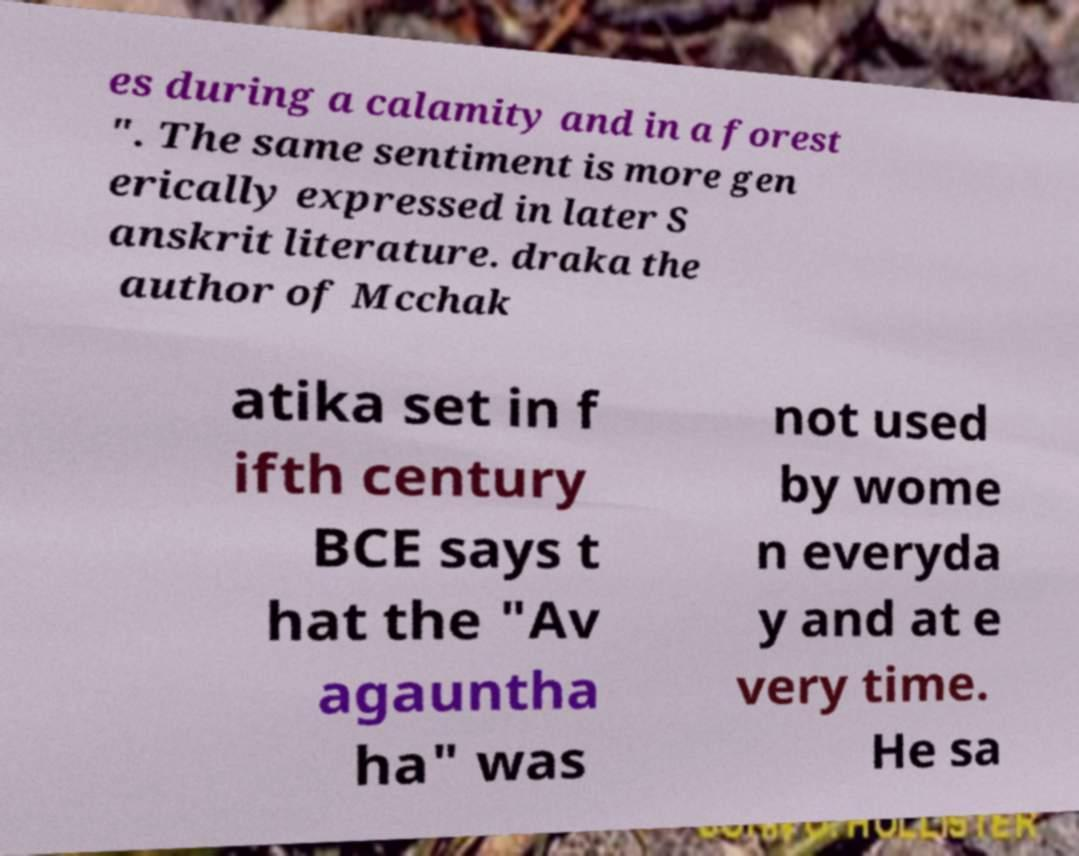Can you accurately transcribe the text from the provided image for me? es during a calamity and in a forest ". The same sentiment is more gen erically expressed in later S anskrit literature. draka the author of Mcchak atika set in f ifth century BCE says t hat the "Av agauntha ha" was not used by wome n everyda y and at e very time. He sa 